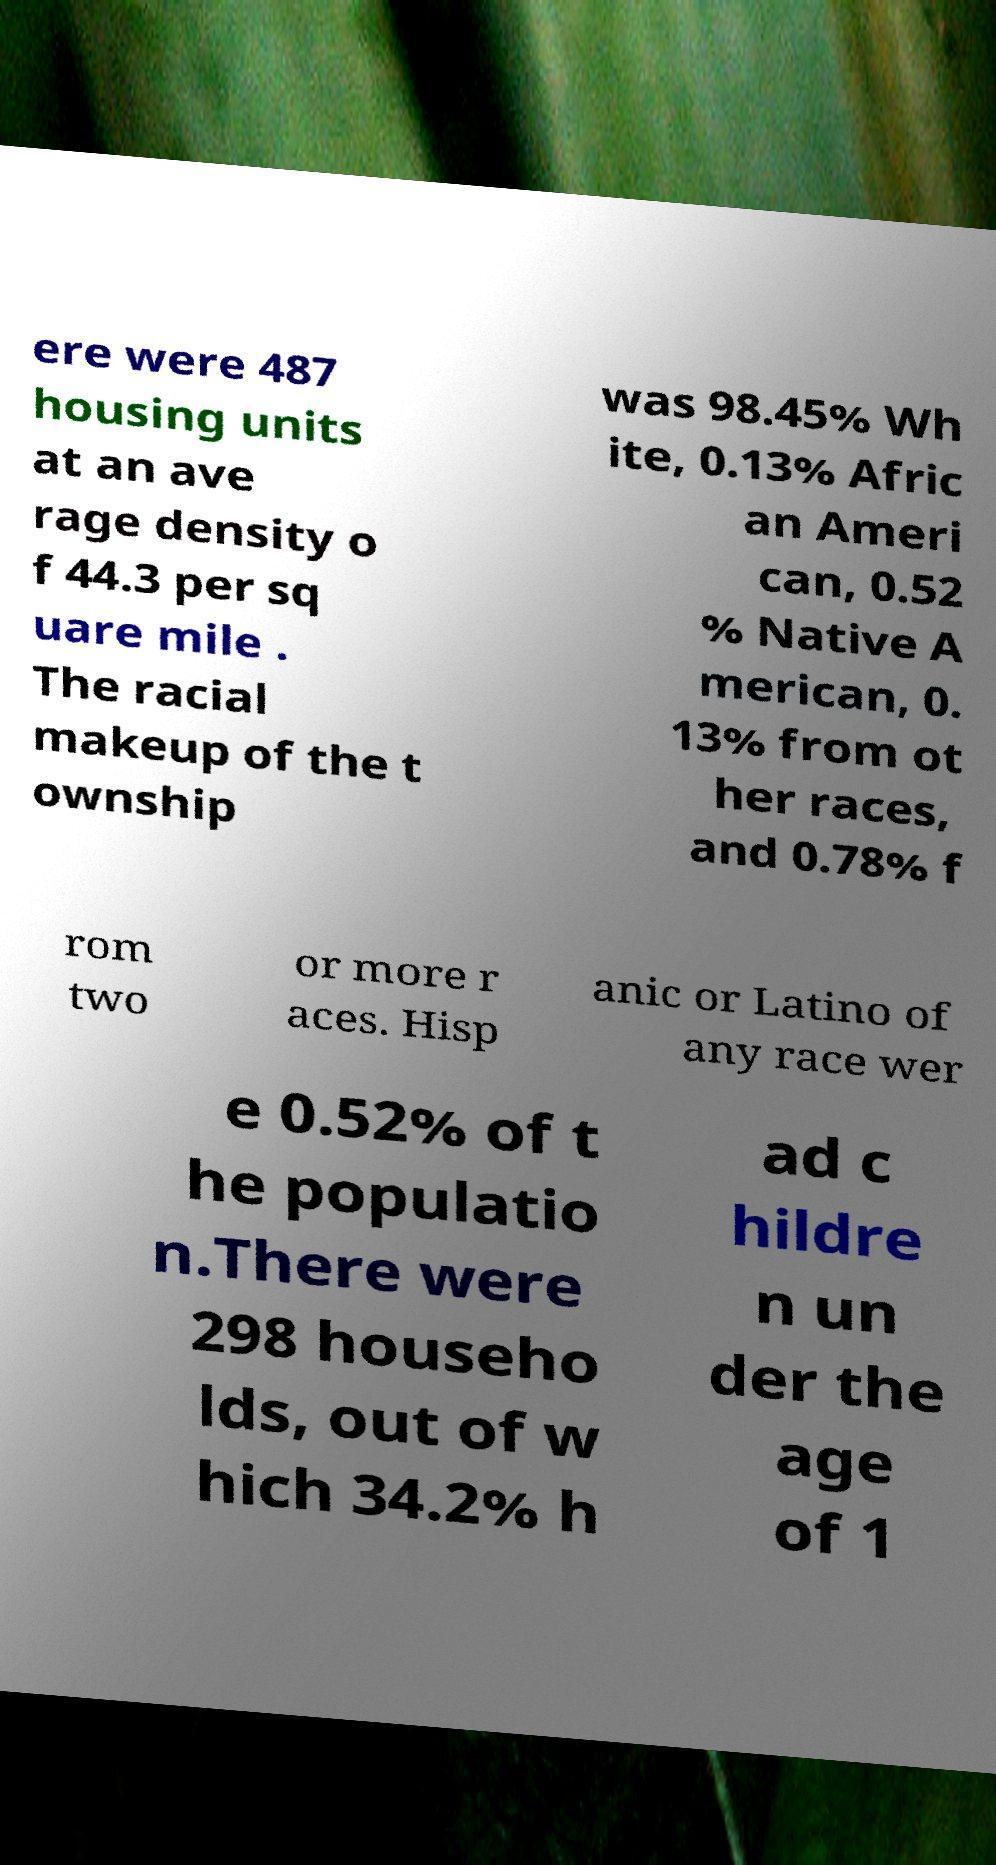What messages or text are displayed in this image? I need them in a readable, typed format. ere were 487 housing units at an ave rage density o f 44.3 per sq uare mile . The racial makeup of the t ownship was 98.45% Wh ite, 0.13% Afric an Ameri can, 0.52 % Native A merican, 0. 13% from ot her races, and 0.78% f rom two or more r aces. Hisp anic or Latino of any race wer e 0.52% of t he populatio n.There were 298 househo lds, out of w hich 34.2% h ad c hildre n un der the age of 1 